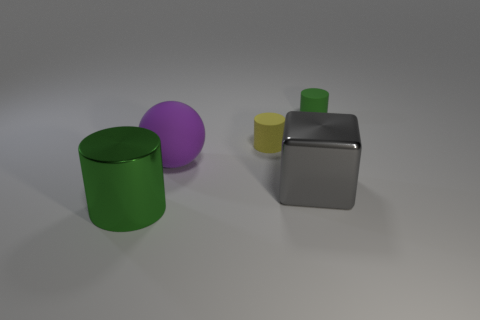The purple thing that is the same material as the yellow object is what shape?
Provide a short and direct response. Sphere. There is a rubber cylinder behind the yellow thing; what number of green cylinders are in front of it?
Make the answer very short. 1. How many green objects are right of the large shiny cylinder and to the left of the large sphere?
Your answer should be very brief. 0. How many other things are made of the same material as the yellow cylinder?
Provide a short and direct response. 2. There is a small cylinder on the left side of the matte cylinder that is to the right of the yellow thing; what is its color?
Keep it short and to the point. Yellow. There is a object behind the tiny yellow cylinder; is its color the same as the sphere?
Provide a succinct answer. No. Is the size of the green metal cylinder the same as the metallic block?
Ensure brevity in your answer.  Yes. There is a thing that is the same size as the yellow rubber cylinder; what is its shape?
Your answer should be very brief. Cylinder. There is a green cylinder in front of the cube; does it have the same size as the metal block?
Offer a terse response. Yes. There is a green cylinder that is the same size as the matte ball; what is it made of?
Your response must be concise. Metal. 